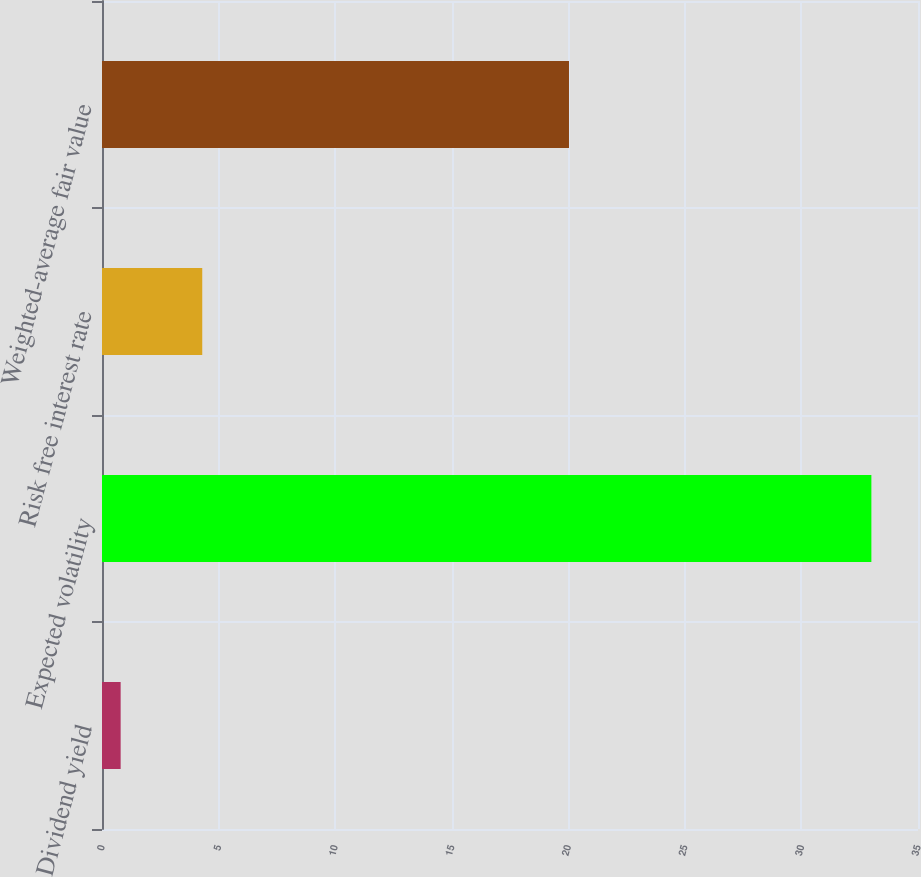Convert chart. <chart><loc_0><loc_0><loc_500><loc_500><bar_chart><fcel>Dividend yield<fcel>Expected volatility<fcel>Risk free interest rate<fcel>Weighted-average fair value<nl><fcel>0.8<fcel>33<fcel>4.3<fcel>20.03<nl></chart> 